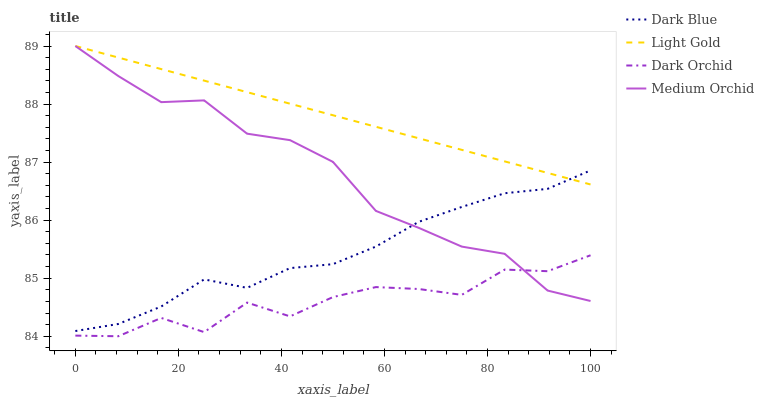Does Dark Orchid have the minimum area under the curve?
Answer yes or no. Yes. Does Light Gold have the maximum area under the curve?
Answer yes or no. Yes. Does Medium Orchid have the minimum area under the curve?
Answer yes or no. No. Does Medium Orchid have the maximum area under the curve?
Answer yes or no. No. Is Light Gold the smoothest?
Answer yes or no. Yes. Is Dark Orchid the roughest?
Answer yes or no. Yes. Is Medium Orchid the smoothest?
Answer yes or no. No. Is Medium Orchid the roughest?
Answer yes or no. No. Does Dark Orchid have the lowest value?
Answer yes or no. Yes. Does Medium Orchid have the lowest value?
Answer yes or no. No. Does Light Gold have the highest value?
Answer yes or no. Yes. Does Dark Orchid have the highest value?
Answer yes or no. No. Is Dark Orchid less than Dark Blue?
Answer yes or no. Yes. Is Dark Blue greater than Dark Orchid?
Answer yes or no. Yes. Does Dark Orchid intersect Medium Orchid?
Answer yes or no. Yes. Is Dark Orchid less than Medium Orchid?
Answer yes or no. No. Is Dark Orchid greater than Medium Orchid?
Answer yes or no. No. Does Dark Orchid intersect Dark Blue?
Answer yes or no. No. 